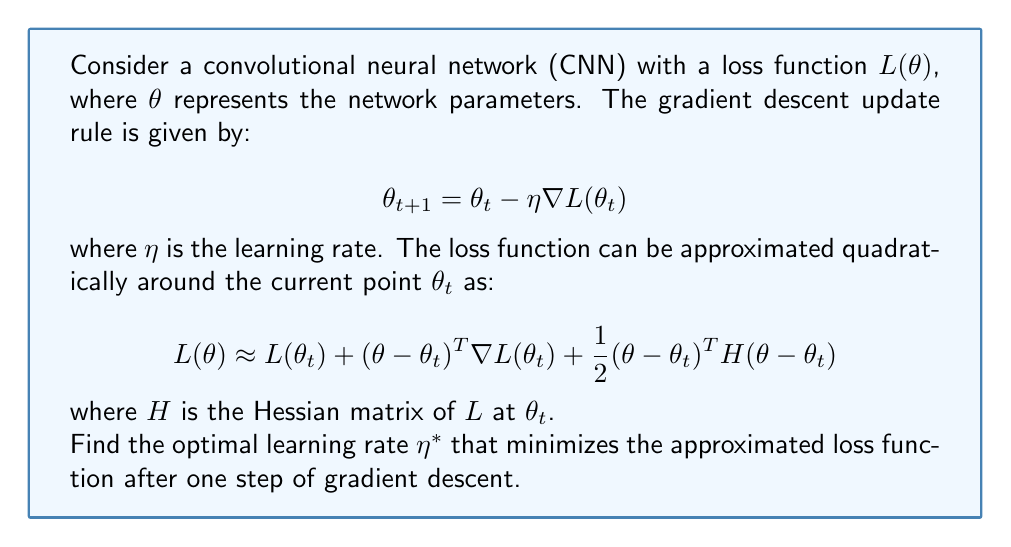Can you solve this math problem? Let's approach this step-by-step:

1) First, we substitute the gradient descent update rule into the quadratic approximation of the loss function:

   $$L(\theta_{t+1}) \approx L(\theta_t) + (\theta_{t+1} - \theta_t)^T \nabla L(\theta_t) + \frac{1}{2}(\theta_{t+1} - \theta_t)^T H (\theta_{t+1} - \theta_t)$$
   $$\approx L(\theta_t) + (-\eta \nabla L(\theta_t))^T \nabla L(\theta_t) + \frac{1}{2}(-\eta \nabla L(\theta_t))^T H (-\eta \nabla L(\theta_t))$$

2) Simplify:
   $$\approx L(\theta_t) - \eta \|\nabla L(\theta_t)\|^2 + \frac{1}{2}\eta^2 \nabla L(\theta_t)^T H \nabla L(\theta_t)$$

3) To find the optimal learning rate, we differentiate with respect to $\eta$ and set it to zero:

   $$\frac{\partial L(\theta_{t+1})}{\partial \eta} \approx -\|\nabla L(\theta_t)\|^2 + \eta \nabla L(\theta_t)^T H \nabla L(\theta_t) = 0$$

4) Solve for $\eta$:

   $$\eta^* = \frac{\|\nabla L(\theta_t)\|^2}{\nabla L(\theta_t)^T H \nabla L(\theta_t)}$$

5) This is the optimal learning rate that minimizes the approximated loss function after one step of gradient descent.
Answer: $$\eta^* = \frac{\|\nabla L(\theta_t)\|^2}{\nabla L(\theta_t)^T H \nabla L(\theta_t)}$$ 